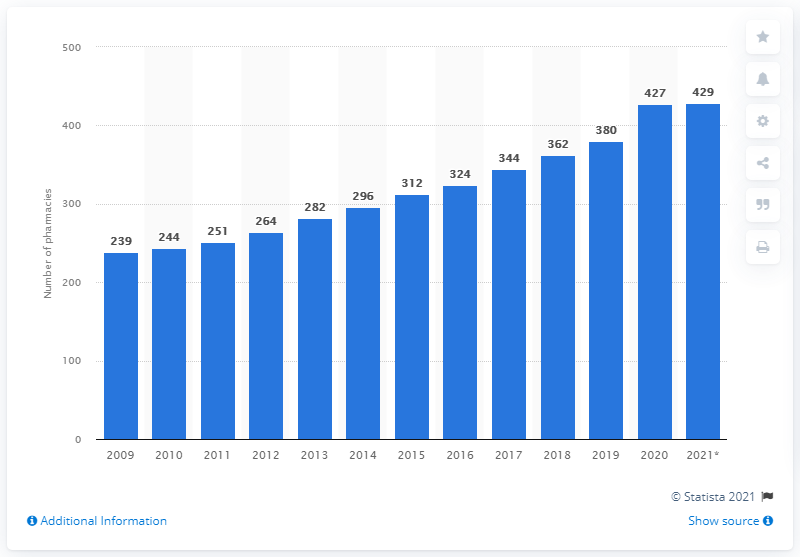Point out several critical features in this image. Apotek 1 operated 380 pharmacies in Norway in 2019. Apotek 1 operated 427 pharmacies in Norway in 2020. 